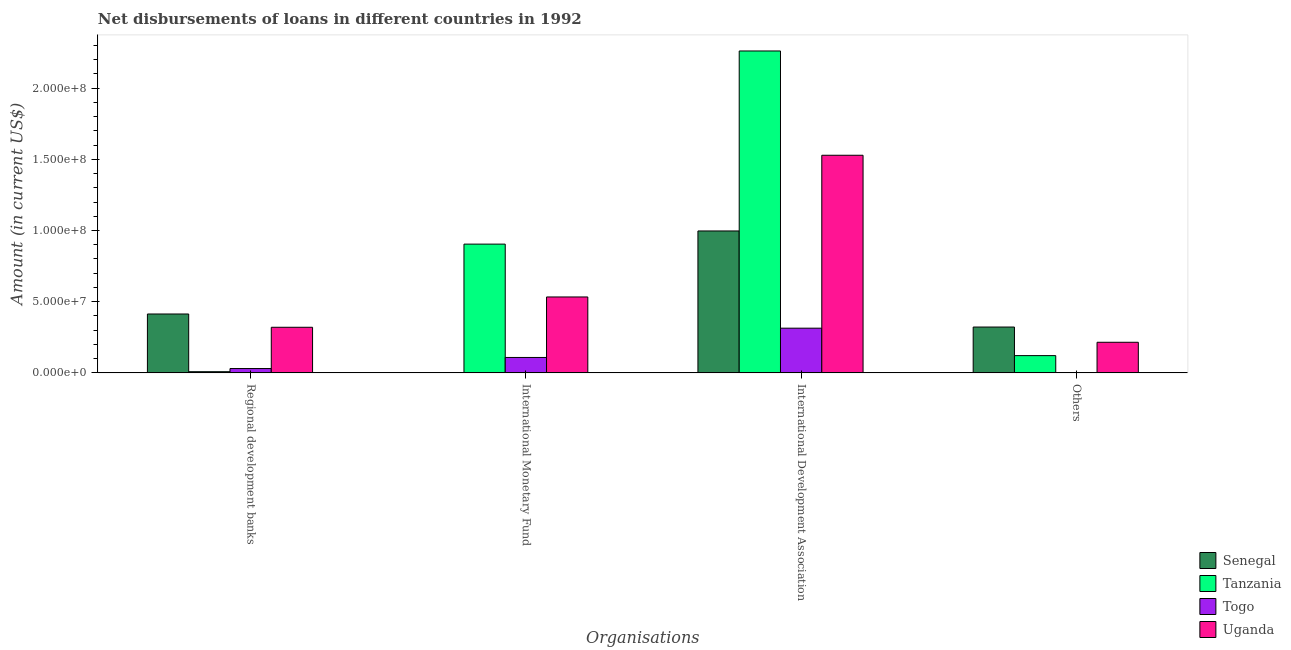How many groups of bars are there?
Keep it short and to the point. 4. How many bars are there on the 3rd tick from the left?
Offer a very short reply. 4. How many bars are there on the 2nd tick from the right?
Provide a succinct answer. 4. What is the label of the 1st group of bars from the left?
Ensure brevity in your answer.  Regional development banks. What is the amount of loan disimbursed by other organisations in Togo?
Keep it short and to the point. 0. Across all countries, what is the maximum amount of loan disimbursed by international monetary fund?
Provide a short and direct response. 9.04e+07. Across all countries, what is the minimum amount of loan disimbursed by international development association?
Provide a short and direct response. 3.14e+07. In which country was the amount of loan disimbursed by international development association maximum?
Make the answer very short. Tanzania. What is the total amount of loan disimbursed by international development association in the graph?
Your answer should be very brief. 5.10e+08. What is the difference between the amount of loan disimbursed by international monetary fund in Tanzania and that in Togo?
Ensure brevity in your answer.  7.96e+07. What is the difference between the amount of loan disimbursed by international monetary fund in Tanzania and the amount of loan disimbursed by international development association in Senegal?
Your answer should be compact. -9.24e+06. What is the average amount of loan disimbursed by other organisations per country?
Your answer should be compact. 1.64e+07. What is the difference between the amount of loan disimbursed by international monetary fund and amount of loan disimbursed by regional development banks in Togo?
Provide a short and direct response. 7.78e+06. What is the ratio of the amount of loan disimbursed by international development association in Uganda to that in Togo?
Give a very brief answer. 4.87. Is the amount of loan disimbursed by international development association in Togo less than that in Tanzania?
Your answer should be very brief. Yes. What is the difference between the highest and the second highest amount of loan disimbursed by other organisations?
Your answer should be very brief. 1.07e+07. What is the difference between the highest and the lowest amount of loan disimbursed by regional development banks?
Keep it short and to the point. 4.05e+07. Is it the case that in every country, the sum of the amount of loan disimbursed by international development association and amount of loan disimbursed by other organisations is greater than the sum of amount of loan disimbursed by international monetary fund and amount of loan disimbursed by regional development banks?
Give a very brief answer. No. How many bars are there?
Offer a very short reply. 14. Are the values on the major ticks of Y-axis written in scientific E-notation?
Give a very brief answer. Yes. Does the graph contain any zero values?
Your answer should be very brief. Yes. Does the graph contain grids?
Give a very brief answer. No. Where does the legend appear in the graph?
Make the answer very short. Bottom right. What is the title of the graph?
Ensure brevity in your answer.  Net disbursements of loans in different countries in 1992. Does "Zambia" appear as one of the legend labels in the graph?
Keep it short and to the point. No. What is the label or title of the X-axis?
Keep it short and to the point. Organisations. What is the label or title of the Y-axis?
Your answer should be compact. Amount (in current US$). What is the Amount (in current US$) of Senegal in Regional development banks?
Your response must be concise. 4.14e+07. What is the Amount (in current US$) in Tanzania in Regional development banks?
Offer a terse response. 8.25e+05. What is the Amount (in current US$) in Togo in Regional development banks?
Make the answer very short. 3.04e+06. What is the Amount (in current US$) of Uganda in Regional development banks?
Give a very brief answer. 3.20e+07. What is the Amount (in current US$) of Senegal in International Monetary Fund?
Your answer should be compact. 0. What is the Amount (in current US$) of Tanzania in International Monetary Fund?
Your response must be concise. 9.04e+07. What is the Amount (in current US$) in Togo in International Monetary Fund?
Keep it short and to the point. 1.08e+07. What is the Amount (in current US$) in Uganda in International Monetary Fund?
Keep it short and to the point. 5.33e+07. What is the Amount (in current US$) of Senegal in International Development Association?
Give a very brief answer. 9.97e+07. What is the Amount (in current US$) of Tanzania in International Development Association?
Give a very brief answer. 2.26e+08. What is the Amount (in current US$) of Togo in International Development Association?
Your answer should be compact. 3.14e+07. What is the Amount (in current US$) in Uganda in International Development Association?
Your answer should be very brief. 1.53e+08. What is the Amount (in current US$) in Senegal in Others?
Provide a succinct answer. 3.22e+07. What is the Amount (in current US$) of Tanzania in Others?
Your response must be concise. 1.21e+07. What is the Amount (in current US$) of Togo in Others?
Give a very brief answer. 0. What is the Amount (in current US$) of Uganda in Others?
Your answer should be very brief. 2.15e+07. Across all Organisations, what is the maximum Amount (in current US$) of Senegal?
Ensure brevity in your answer.  9.97e+07. Across all Organisations, what is the maximum Amount (in current US$) in Tanzania?
Your answer should be very brief. 2.26e+08. Across all Organisations, what is the maximum Amount (in current US$) of Togo?
Keep it short and to the point. 3.14e+07. Across all Organisations, what is the maximum Amount (in current US$) in Uganda?
Offer a terse response. 1.53e+08. Across all Organisations, what is the minimum Amount (in current US$) in Senegal?
Give a very brief answer. 0. Across all Organisations, what is the minimum Amount (in current US$) of Tanzania?
Give a very brief answer. 8.25e+05. Across all Organisations, what is the minimum Amount (in current US$) of Togo?
Your answer should be very brief. 0. Across all Organisations, what is the minimum Amount (in current US$) of Uganda?
Give a very brief answer. 2.15e+07. What is the total Amount (in current US$) in Senegal in the graph?
Provide a short and direct response. 1.73e+08. What is the total Amount (in current US$) of Tanzania in the graph?
Your answer should be very brief. 3.29e+08. What is the total Amount (in current US$) in Togo in the graph?
Offer a terse response. 4.52e+07. What is the total Amount (in current US$) of Uganda in the graph?
Provide a short and direct response. 2.60e+08. What is the difference between the Amount (in current US$) in Tanzania in Regional development banks and that in International Monetary Fund?
Offer a very short reply. -8.96e+07. What is the difference between the Amount (in current US$) of Togo in Regional development banks and that in International Monetary Fund?
Your response must be concise. -7.78e+06. What is the difference between the Amount (in current US$) in Uganda in Regional development banks and that in International Monetary Fund?
Provide a succinct answer. -2.13e+07. What is the difference between the Amount (in current US$) in Senegal in Regional development banks and that in International Development Association?
Give a very brief answer. -5.83e+07. What is the difference between the Amount (in current US$) of Tanzania in Regional development banks and that in International Development Association?
Offer a terse response. -2.25e+08. What is the difference between the Amount (in current US$) in Togo in Regional development banks and that in International Development Association?
Make the answer very short. -2.84e+07. What is the difference between the Amount (in current US$) in Uganda in Regional development banks and that in International Development Association?
Provide a succinct answer. -1.21e+08. What is the difference between the Amount (in current US$) of Senegal in Regional development banks and that in Others?
Make the answer very short. 9.17e+06. What is the difference between the Amount (in current US$) of Tanzania in Regional development banks and that in Others?
Make the answer very short. -1.13e+07. What is the difference between the Amount (in current US$) in Uganda in Regional development banks and that in Others?
Make the answer very short. 1.05e+07. What is the difference between the Amount (in current US$) in Tanzania in International Monetary Fund and that in International Development Association?
Your response must be concise. -1.36e+08. What is the difference between the Amount (in current US$) of Togo in International Monetary Fund and that in International Development Association?
Your answer should be compact. -2.06e+07. What is the difference between the Amount (in current US$) in Uganda in International Monetary Fund and that in International Development Association?
Your answer should be compact. -9.95e+07. What is the difference between the Amount (in current US$) in Tanzania in International Monetary Fund and that in Others?
Ensure brevity in your answer.  7.83e+07. What is the difference between the Amount (in current US$) in Uganda in International Monetary Fund and that in Others?
Your response must be concise. 3.18e+07. What is the difference between the Amount (in current US$) in Senegal in International Development Association and that in Others?
Give a very brief answer. 6.75e+07. What is the difference between the Amount (in current US$) of Tanzania in International Development Association and that in Others?
Provide a short and direct response. 2.14e+08. What is the difference between the Amount (in current US$) in Uganda in International Development Association and that in Others?
Make the answer very short. 1.31e+08. What is the difference between the Amount (in current US$) in Senegal in Regional development banks and the Amount (in current US$) in Tanzania in International Monetary Fund?
Offer a very short reply. -4.91e+07. What is the difference between the Amount (in current US$) of Senegal in Regional development banks and the Amount (in current US$) of Togo in International Monetary Fund?
Offer a very short reply. 3.05e+07. What is the difference between the Amount (in current US$) in Senegal in Regional development banks and the Amount (in current US$) in Uganda in International Monetary Fund?
Give a very brief answer. -1.20e+07. What is the difference between the Amount (in current US$) in Tanzania in Regional development banks and the Amount (in current US$) in Togo in International Monetary Fund?
Your answer should be very brief. -9.99e+06. What is the difference between the Amount (in current US$) in Tanzania in Regional development banks and the Amount (in current US$) in Uganda in International Monetary Fund?
Keep it short and to the point. -5.25e+07. What is the difference between the Amount (in current US$) of Togo in Regional development banks and the Amount (in current US$) of Uganda in International Monetary Fund?
Your response must be concise. -5.03e+07. What is the difference between the Amount (in current US$) in Senegal in Regional development banks and the Amount (in current US$) in Tanzania in International Development Association?
Keep it short and to the point. -1.85e+08. What is the difference between the Amount (in current US$) of Senegal in Regional development banks and the Amount (in current US$) of Togo in International Development Association?
Give a very brief answer. 9.96e+06. What is the difference between the Amount (in current US$) in Senegal in Regional development banks and the Amount (in current US$) in Uganda in International Development Association?
Keep it short and to the point. -1.11e+08. What is the difference between the Amount (in current US$) in Tanzania in Regional development banks and the Amount (in current US$) in Togo in International Development Association?
Keep it short and to the point. -3.06e+07. What is the difference between the Amount (in current US$) in Tanzania in Regional development banks and the Amount (in current US$) in Uganda in International Development Association?
Make the answer very short. -1.52e+08. What is the difference between the Amount (in current US$) in Togo in Regional development banks and the Amount (in current US$) in Uganda in International Development Association?
Keep it short and to the point. -1.50e+08. What is the difference between the Amount (in current US$) in Senegal in Regional development banks and the Amount (in current US$) in Tanzania in Others?
Provide a short and direct response. 2.92e+07. What is the difference between the Amount (in current US$) in Senegal in Regional development banks and the Amount (in current US$) in Uganda in Others?
Offer a very short reply. 1.99e+07. What is the difference between the Amount (in current US$) of Tanzania in Regional development banks and the Amount (in current US$) of Uganda in Others?
Your answer should be compact. -2.07e+07. What is the difference between the Amount (in current US$) in Togo in Regional development banks and the Amount (in current US$) in Uganda in Others?
Ensure brevity in your answer.  -1.85e+07. What is the difference between the Amount (in current US$) in Tanzania in International Monetary Fund and the Amount (in current US$) in Togo in International Development Association?
Offer a terse response. 5.90e+07. What is the difference between the Amount (in current US$) of Tanzania in International Monetary Fund and the Amount (in current US$) of Uganda in International Development Association?
Offer a very short reply. -6.24e+07. What is the difference between the Amount (in current US$) of Togo in International Monetary Fund and the Amount (in current US$) of Uganda in International Development Association?
Offer a very short reply. -1.42e+08. What is the difference between the Amount (in current US$) of Tanzania in International Monetary Fund and the Amount (in current US$) of Uganda in Others?
Keep it short and to the point. 6.89e+07. What is the difference between the Amount (in current US$) in Togo in International Monetary Fund and the Amount (in current US$) in Uganda in Others?
Your answer should be compact. -1.07e+07. What is the difference between the Amount (in current US$) of Senegal in International Development Association and the Amount (in current US$) of Tanzania in Others?
Provide a short and direct response. 8.76e+07. What is the difference between the Amount (in current US$) in Senegal in International Development Association and the Amount (in current US$) in Uganda in Others?
Provide a succinct answer. 7.82e+07. What is the difference between the Amount (in current US$) of Tanzania in International Development Association and the Amount (in current US$) of Uganda in Others?
Your response must be concise. 2.05e+08. What is the difference between the Amount (in current US$) of Togo in International Development Association and the Amount (in current US$) of Uganda in Others?
Your answer should be compact. 9.90e+06. What is the average Amount (in current US$) in Senegal per Organisations?
Keep it short and to the point. 4.33e+07. What is the average Amount (in current US$) of Tanzania per Organisations?
Provide a succinct answer. 8.24e+07. What is the average Amount (in current US$) of Togo per Organisations?
Provide a succinct answer. 1.13e+07. What is the average Amount (in current US$) in Uganda per Organisations?
Ensure brevity in your answer.  6.49e+07. What is the difference between the Amount (in current US$) in Senegal and Amount (in current US$) in Tanzania in Regional development banks?
Give a very brief answer. 4.05e+07. What is the difference between the Amount (in current US$) in Senegal and Amount (in current US$) in Togo in Regional development banks?
Provide a succinct answer. 3.83e+07. What is the difference between the Amount (in current US$) of Senegal and Amount (in current US$) of Uganda in Regional development banks?
Offer a very short reply. 9.32e+06. What is the difference between the Amount (in current US$) in Tanzania and Amount (in current US$) in Togo in Regional development banks?
Provide a short and direct response. -2.21e+06. What is the difference between the Amount (in current US$) in Tanzania and Amount (in current US$) in Uganda in Regional development banks?
Your response must be concise. -3.12e+07. What is the difference between the Amount (in current US$) in Togo and Amount (in current US$) in Uganda in Regional development banks?
Ensure brevity in your answer.  -2.90e+07. What is the difference between the Amount (in current US$) in Tanzania and Amount (in current US$) in Togo in International Monetary Fund?
Provide a short and direct response. 7.96e+07. What is the difference between the Amount (in current US$) of Tanzania and Amount (in current US$) of Uganda in International Monetary Fund?
Give a very brief answer. 3.71e+07. What is the difference between the Amount (in current US$) in Togo and Amount (in current US$) in Uganda in International Monetary Fund?
Your response must be concise. -4.25e+07. What is the difference between the Amount (in current US$) in Senegal and Amount (in current US$) in Tanzania in International Development Association?
Offer a terse response. -1.26e+08. What is the difference between the Amount (in current US$) of Senegal and Amount (in current US$) of Togo in International Development Association?
Your answer should be very brief. 6.83e+07. What is the difference between the Amount (in current US$) of Senegal and Amount (in current US$) of Uganda in International Development Association?
Ensure brevity in your answer.  -5.32e+07. What is the difference between the Amount (in current US$) of Tanzania and Amount (in current US$) of Togo in International Development Association?
Offer a terse response. 1.95e+08. What is the difference between the Amount (in current US$) of Tanzania and Amount (in current US$) of Uganda in International Development Association?
Make the answer very short. 7.32e+07. What is the difference between the Amount (in current US$) in Togo and Amount (in current US$) in Uganda in International Development Association?
Your answer should be very brief. -1.21e+08. What is the difference between the Amount (in current US$) of Senegal and Amount (in current US$) of Tanzania in Others?
Your response must be concise. 2.01e+07. What is the difference between the Amount (in current US$) in Senegal and Amount (in current US$) in Uganda in Others?
Your answer should be compact. 1.07e+07. What is the difference between the Amount (in current US$) in Tanzania and Amount (in current US$) in Uganda in Others?
Ensure brevity in your answer.  -9.37e+06. What is the ratio of the Amount (in current US$) in Tanzania in Regional development banks to that in International Monetary Fund?
Your answer should be very brief. 0.01. What is the ratio of the Amount (in current US$) of Togo in Regional development banks to that in International Monetary Fund?
Your response must be concise. 0.28. What is the ratio of the Amount (in current US$) of Uganda in Regional development banks to that in International Monetary Fund?
Provide a short and direct response. 0.6. What is the ratio of the Amount (in current US$) in Senegal in Regional development banks to that in International Development Association?
Keep it short and to the point. 0.41. What is the ratio of the Amount (in current US$) of Tanzania in Regional development banks to that in International Development Association?
Provide a succinct answer. 0. What is the ratio of the Amount (in current US$) in Togo in Regional development banks to that in International Development Association?
Your answer should be compact. 0.1. What is the ratio of the Amount (in current US$) of Uganda in Regional development banks to that in International Development Association?
Offer a terse response. 0.21. What is the ratio of the Amount (in current US$) in Senegal in Regional development banks to that in Others?
Your answer should be very brief. 1.28. What is the ratio of the Amount (in current US$) in Tanzania in Regional development banks to that in Others?
Your answer should be very brief. 0.07. What is the ratio of the Amount (in current US$) of Uganda in Regional development banks to that in Others?
Ensure brevity in your answer.  1.49. What is the ratio of the Amount (in current US$) of Togo in International Monetary Fund to that in International Development Association?
Your answer should be very brief. 0.34. What is the ratio of the Amount (in current US$) in Uganda in International Monetary Fund to that in International Development Association?
Offer a terse response. 0.35. What is the ratio of the Amount (in current US$) in Tanzania in International Monetary Fund to that in Others?
Ensure brevity in your answer.  7.46. What is the ratio of the Amount (in current US$) of Uganda in International Monetary Fund to that in Others?
Keep it short and to the point. 2.48. What is the ratio of the Amount (in current US$) in Senegal in International Development Association to that in Others?
Your answer should be very brief. 3.1. What is the ratio of the Amount (in current US$) of Tanzania in International Development Association to that in Others?
Offer a terse response. 18.66. What is the ratio of the Amount (in current US$) of Uganda in International Development Association to that in Others?
Provide a succinct answer. 7.11. What is the difference between the highest and the second highest Amount (in current US$) in Senegal?
Ensure brevity in your answer.  5.83e+07. What is the difference between the highest and the second highest Amount (in current US$) of Tanzania?
Offer a terse response. 1.36e+08. What is the difference between the highest and the second highest Amount (in current US$) of Togo?
Ensure brevity in your answer.  2.06e+07. What is the difference between the highest and the second highest Amount (in current US$) of Uganda?
Give a very brief answer. 9.95e+07. What is the difference between the highest and the lowest Amount (in current US$) in Senegal?
Offer a terse response. 9.97e+07. What is the difference between the highest and the lowest Amount (in current US$) of Tanzania?
Make the answer very short. 2.25e+08. What is the difference between the highest and the lowest Amount (in current US$) of Togo?
Provide a short and direct response. 3.14e+07. What is the difference between the highest and the lowest Amount (in current US$) of Uganda?
Make the answer very short. 1.31e+08. 